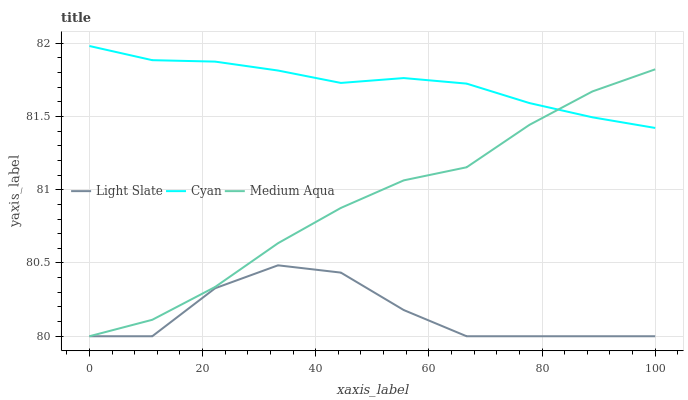Does Light Slate have the minimum area under the curve?
Answer yes or no. Yes. Does Cyan have the maximum area under the curve?
Answer yes or no. Yes. Does Medium Aqua have the minimum area under the curve?
Answer yes or no. No. Does Medium Aqua have the maximum area under the curve?
Answer yes or no. No. Is Cyan the smoothest?
Answer yes or no. Yes. Is Light Slate the roughest?
Answer yes or no. Yes. Is Medium Aqua the smoothest?
Answer yes or no. No. Is Medium Aqua the roughest?
Answer yes or no. No. Does Light Slate have the lowest value?
Answer yes or no. Yes. Does Cyan have the lowest value?
Answer yes or no. No. Does Cyan have the highest value?
Answer yes or no. Yes. Does Medium Aqua have the highest value?
Answer yes or no. No. Is Light Slate less than Cyan?
Answer yes or no. Yes. Is Cyan greater than Light Slate?
Answer yes or no. Yes. Does Light Slate intersect Medium Aqua?
Answer yes or no. Yes. Is Light Slate less than Medium Aqua?
Answer yes or no. No. Is Light Slate greater than Medium Aqua?
Answer yes or no. No. Does Light Slate intersect Cyan?
Answer yes or no. No. 